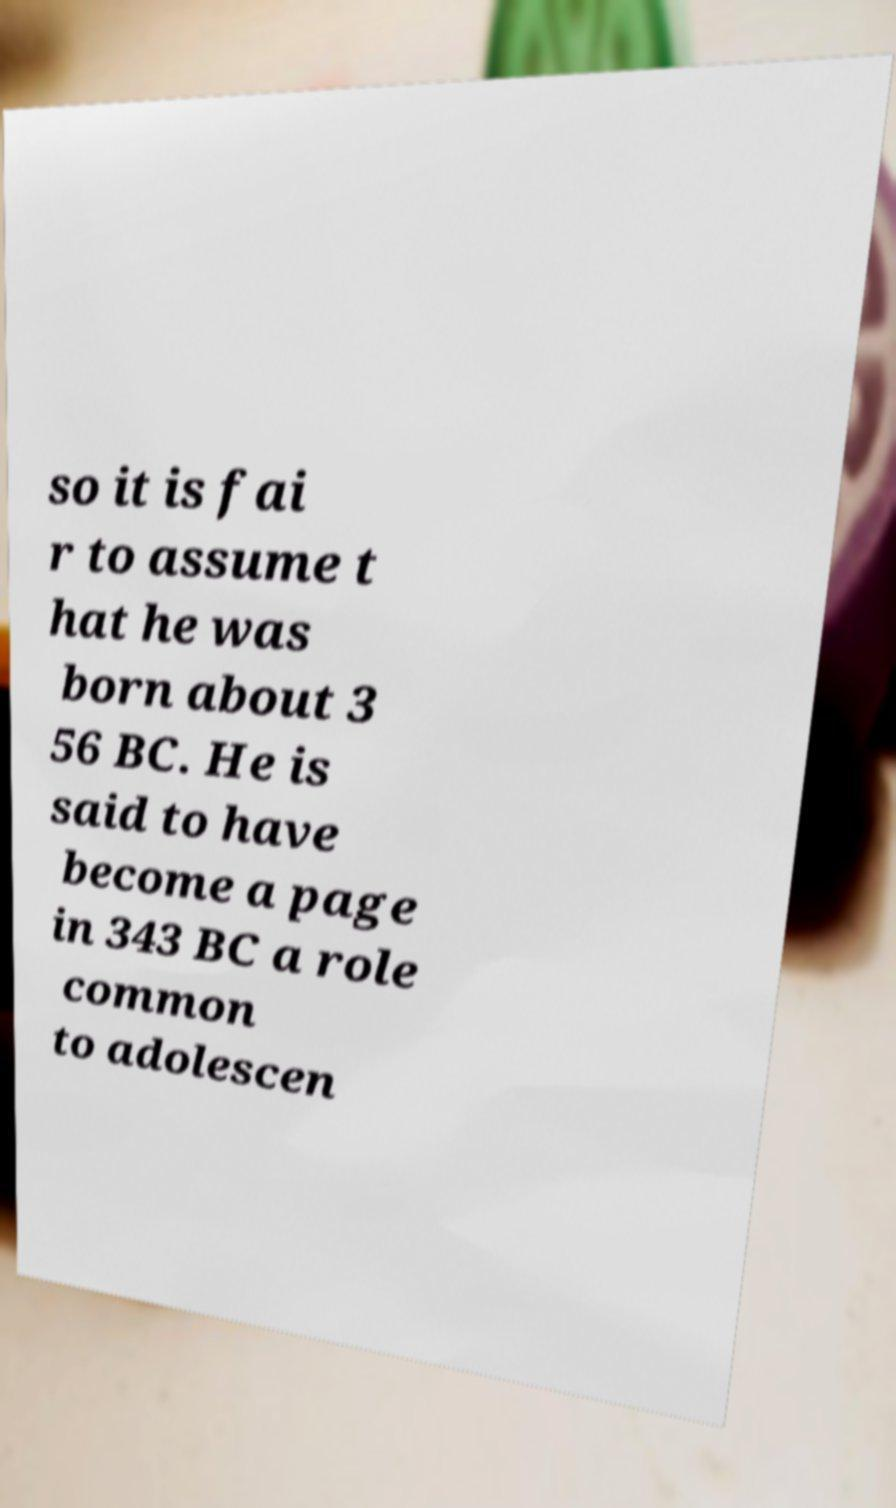Can you read and provide the text displayed in the image?This photo seems to have some interesting text. Can you extract and type it out for me? so it is fai r to assume t hat he was born about 3 56 BC. He is said to have become a page in 343 BC a role common to adolescen 